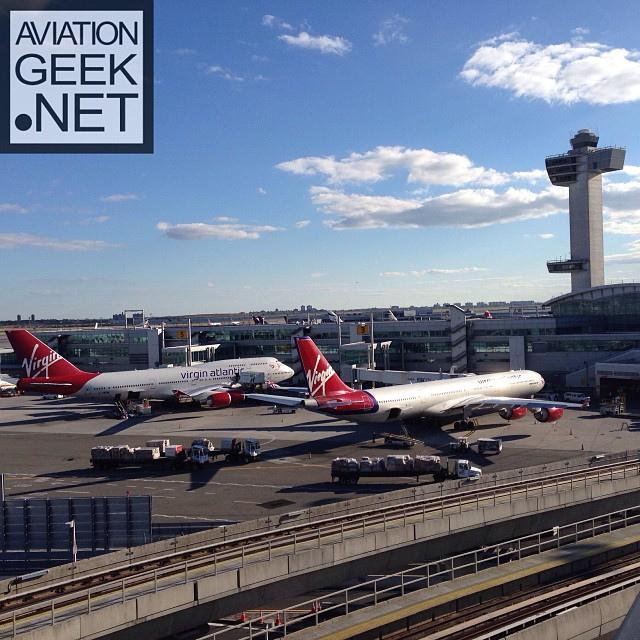What other item did the company whose name appears on the large vehicle make? phones 